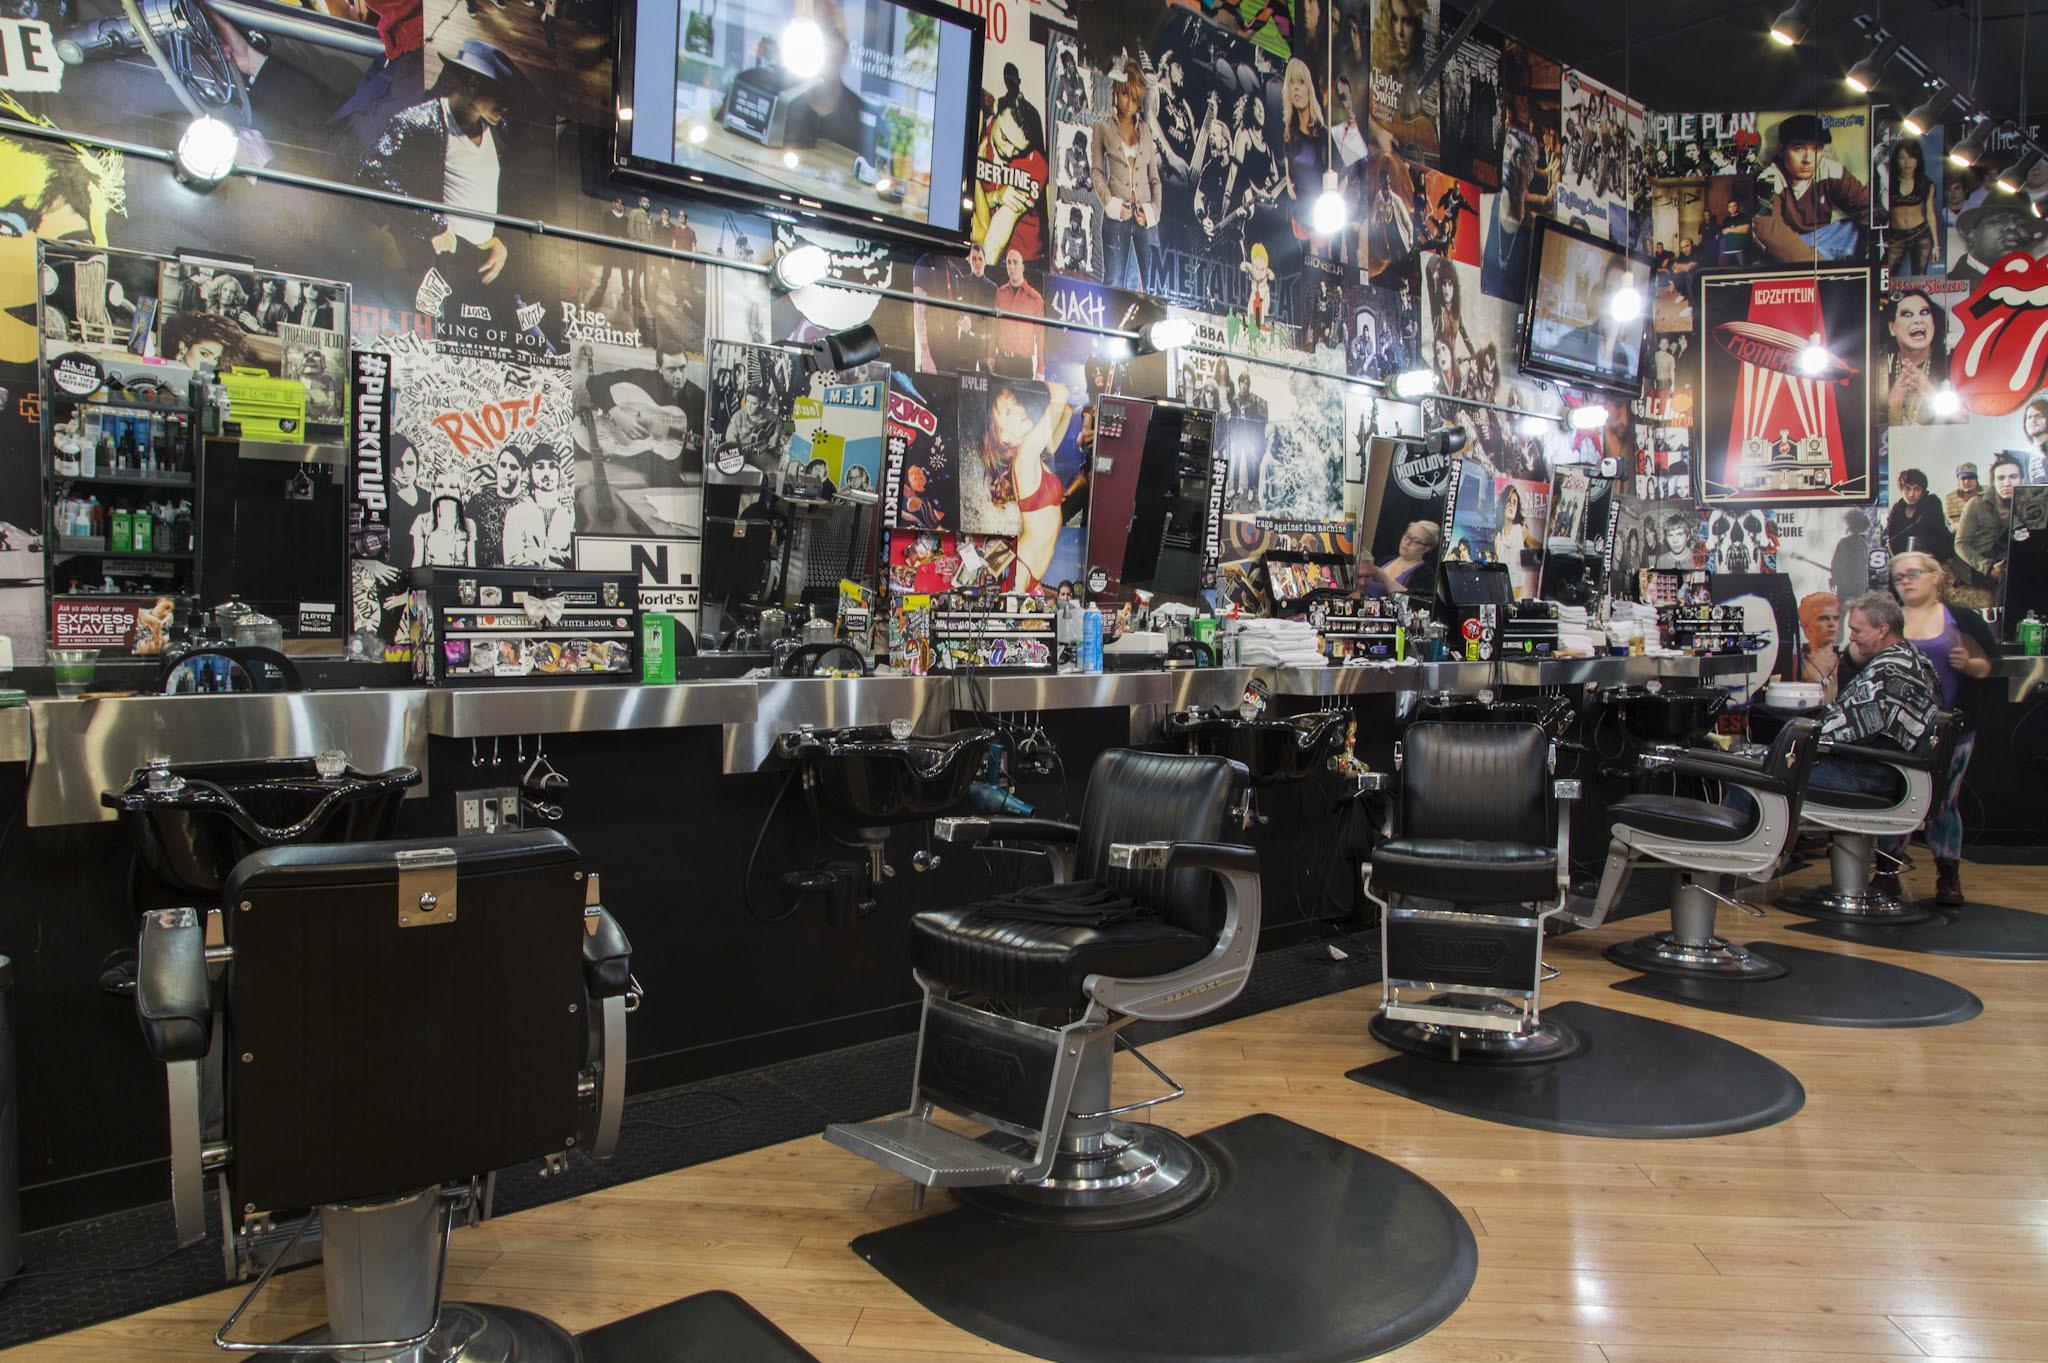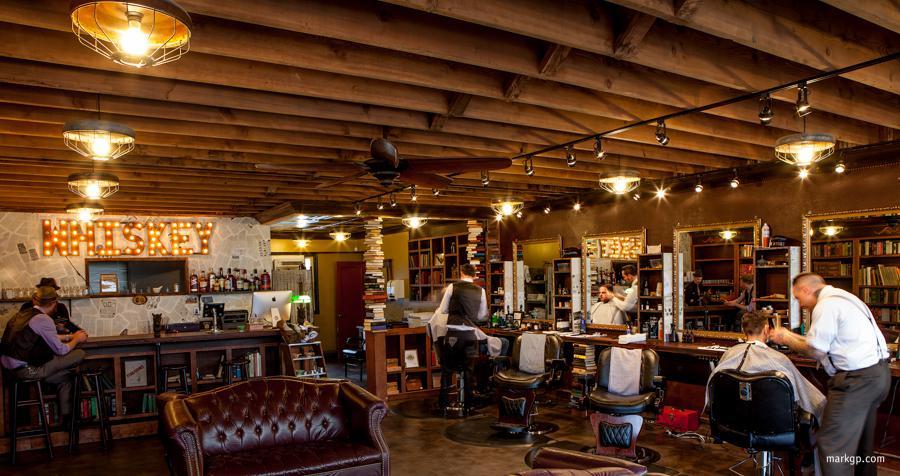The first image is the image on the left, the second image is the image on the right. For the images displayed, is the sentence "There are at least two people in the image on the right." factually correct? Answer yes or no. Yes. 